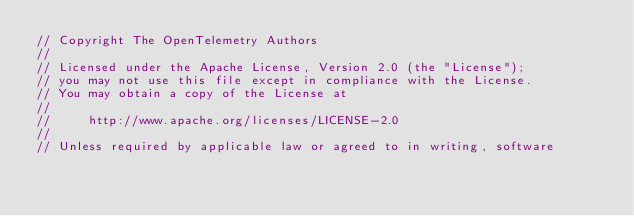Convert code to text. <code><loc_0><loc_0><loc_500><loc_500><_Go_>// Copyright The OpenTelemetry Authors
//
// Licensed under the Apache License, Version 2.0 (the "License");
// you may not use this file except in compliance with the License.
// You may obtain a copy of the License at
//
//     http://www.apache.org/licenses/LICENSE-2.0
//
// Unless required by applicable law or agreed to in writing, software</code> 